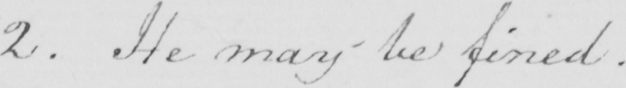Can you tell me what this handwritten text says? 2 . He may be fined 